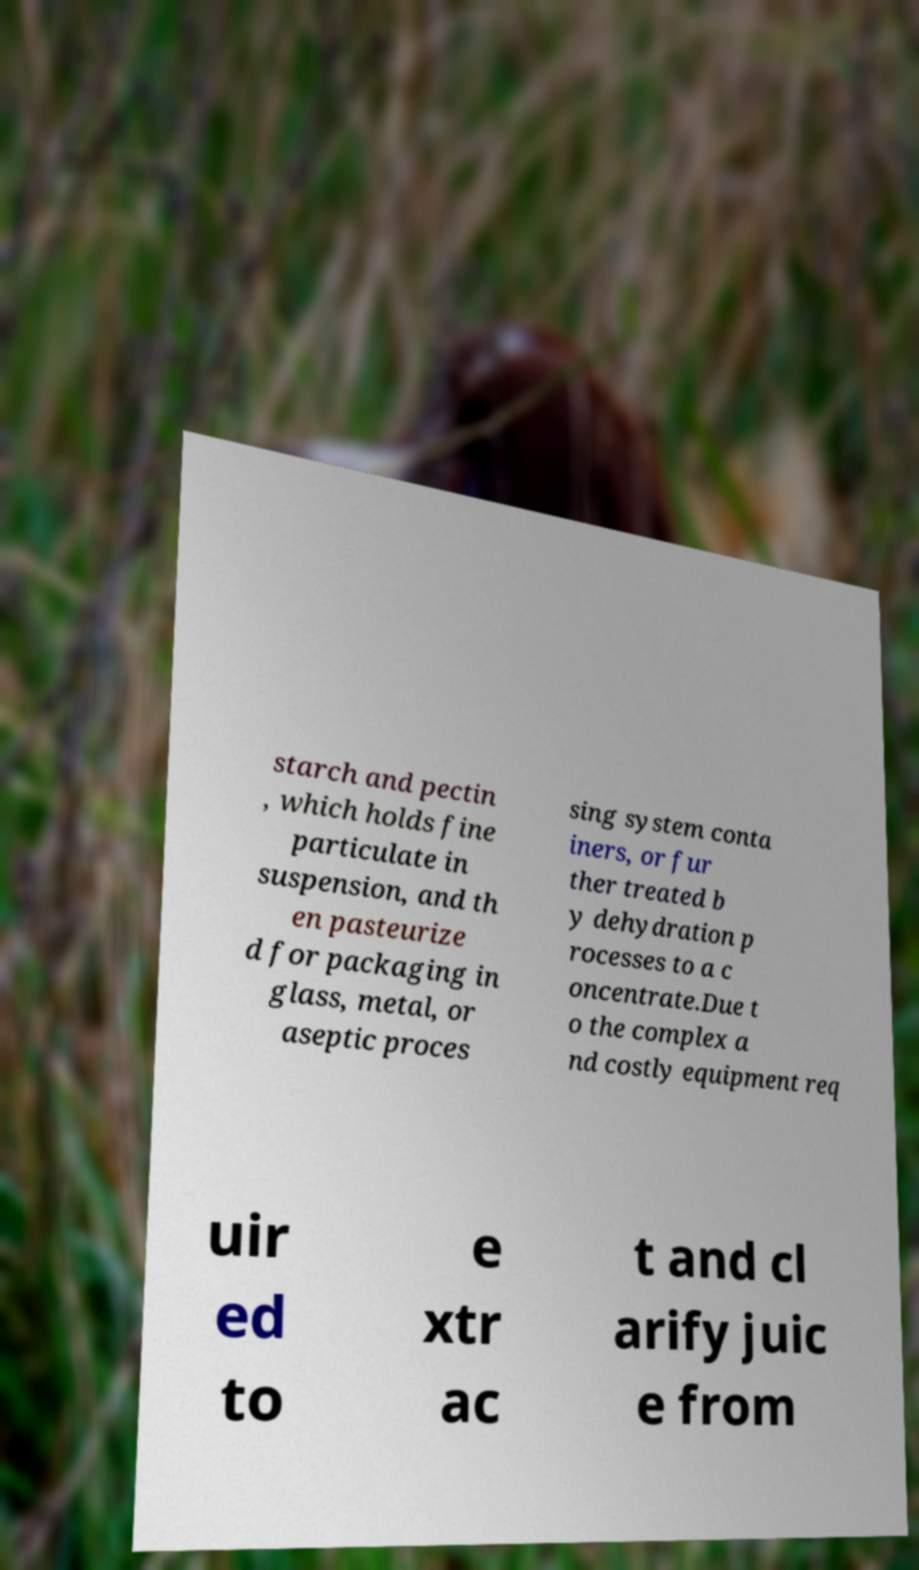What messages or text are displayed in this image? I need them in a readable, typed format. starch and pectin , which holds fine particulate in suspension, and th en pasteurize d for packaging in glass, metal, or aseptic proces sing system conta iners, or fur ther treated b y dehydration p rocesses to a c oncentrate.Due t o the complex a nd costly equipment req uir ed to e xtr ac t and cl arify juic e from 